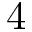<formula> <loc_0><loc_0><loc_500><loc_500>4</formula> 